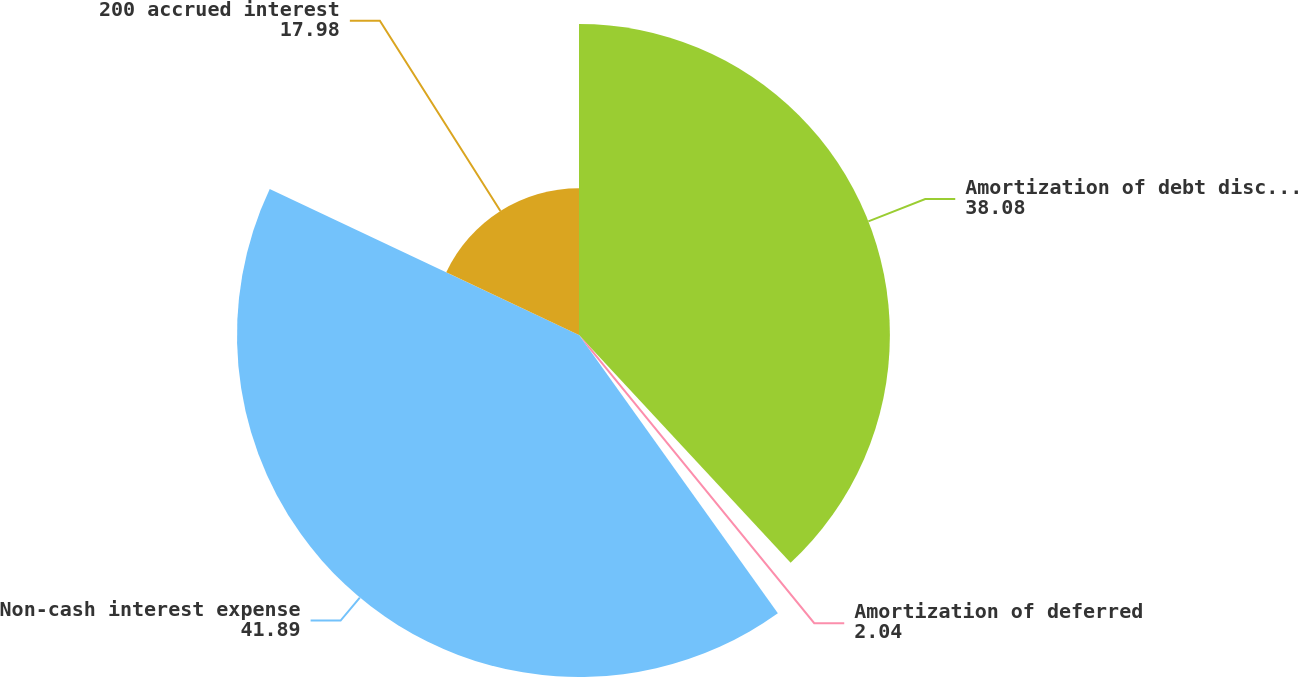Convert chart. <chart><loc_0><loc_0><loc_500><loc_500><pie_chart><fcel>Amortization of debt discount<fcel>Amortization of deferred<fcel>Non-cash interest expense<fcel>200 accrued interest<nl><fcel>38.08%<fcel>2.04%<fcel>41.89%<fcel>17.98%<nl></chart> 